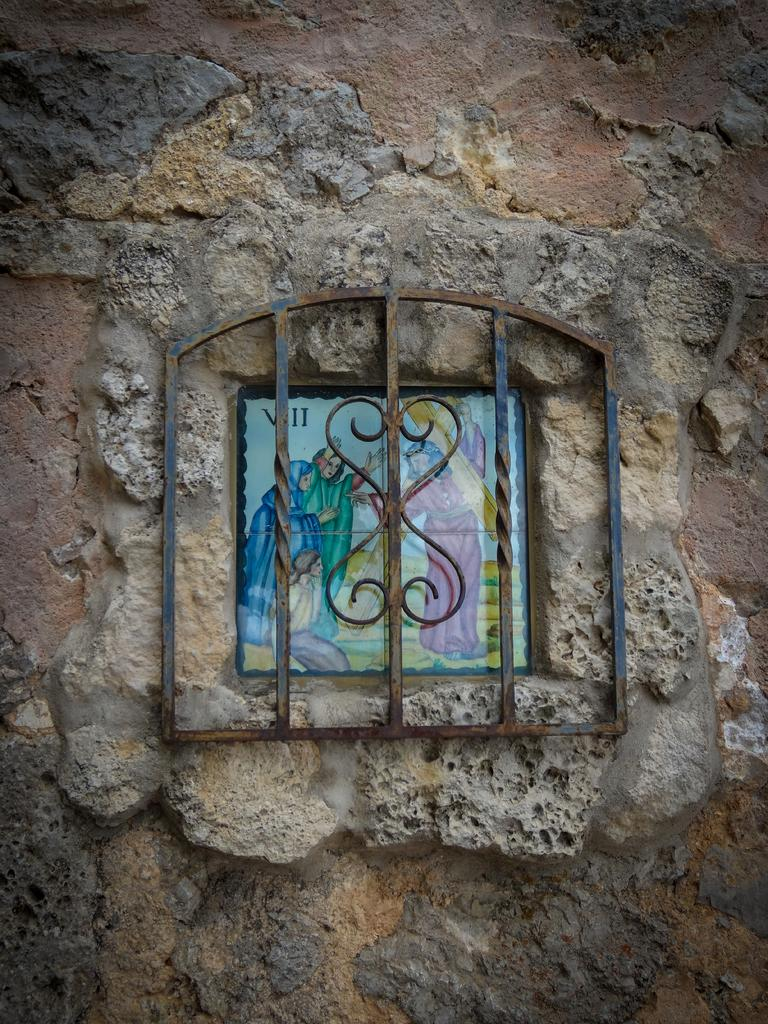What is the main object in the image? There is a frame in the image. What can be seen attached to the wall in the image? There are metal rods on the wall in the image. How many books are stacked on the pot in the image? There is no pot or books present in the image. 